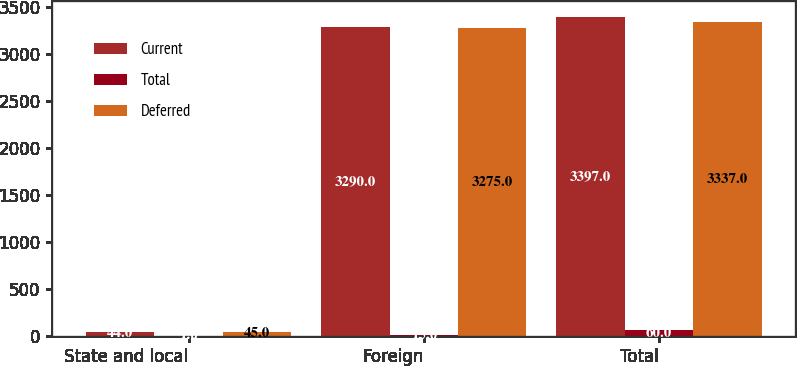Convert chart. <chart><loc_0><loc_0><loc_500><loc_500><stacked_bar_chart><ecel><fcel>State and local<fcel>Foreign<fcel>Total<nl><fcel>Current<fcel>44<fcel>3290<fcel>3397<nl><fcel>Total<fcel>1<fcel>15<fcel>60<nl><fcel>Deferred<fcel>45<fcel>3275<fcel>3337<nl></chart> 